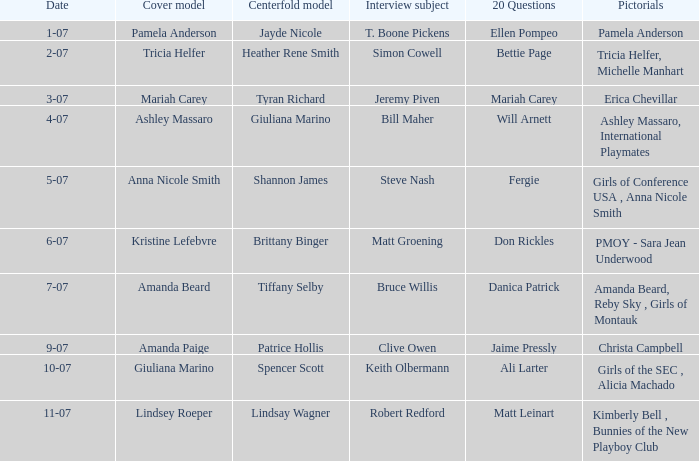List the pictorals from issues when lindsey roeper was the cover model. Kimberly Bell , Bunnies of the New Playboy Club. 